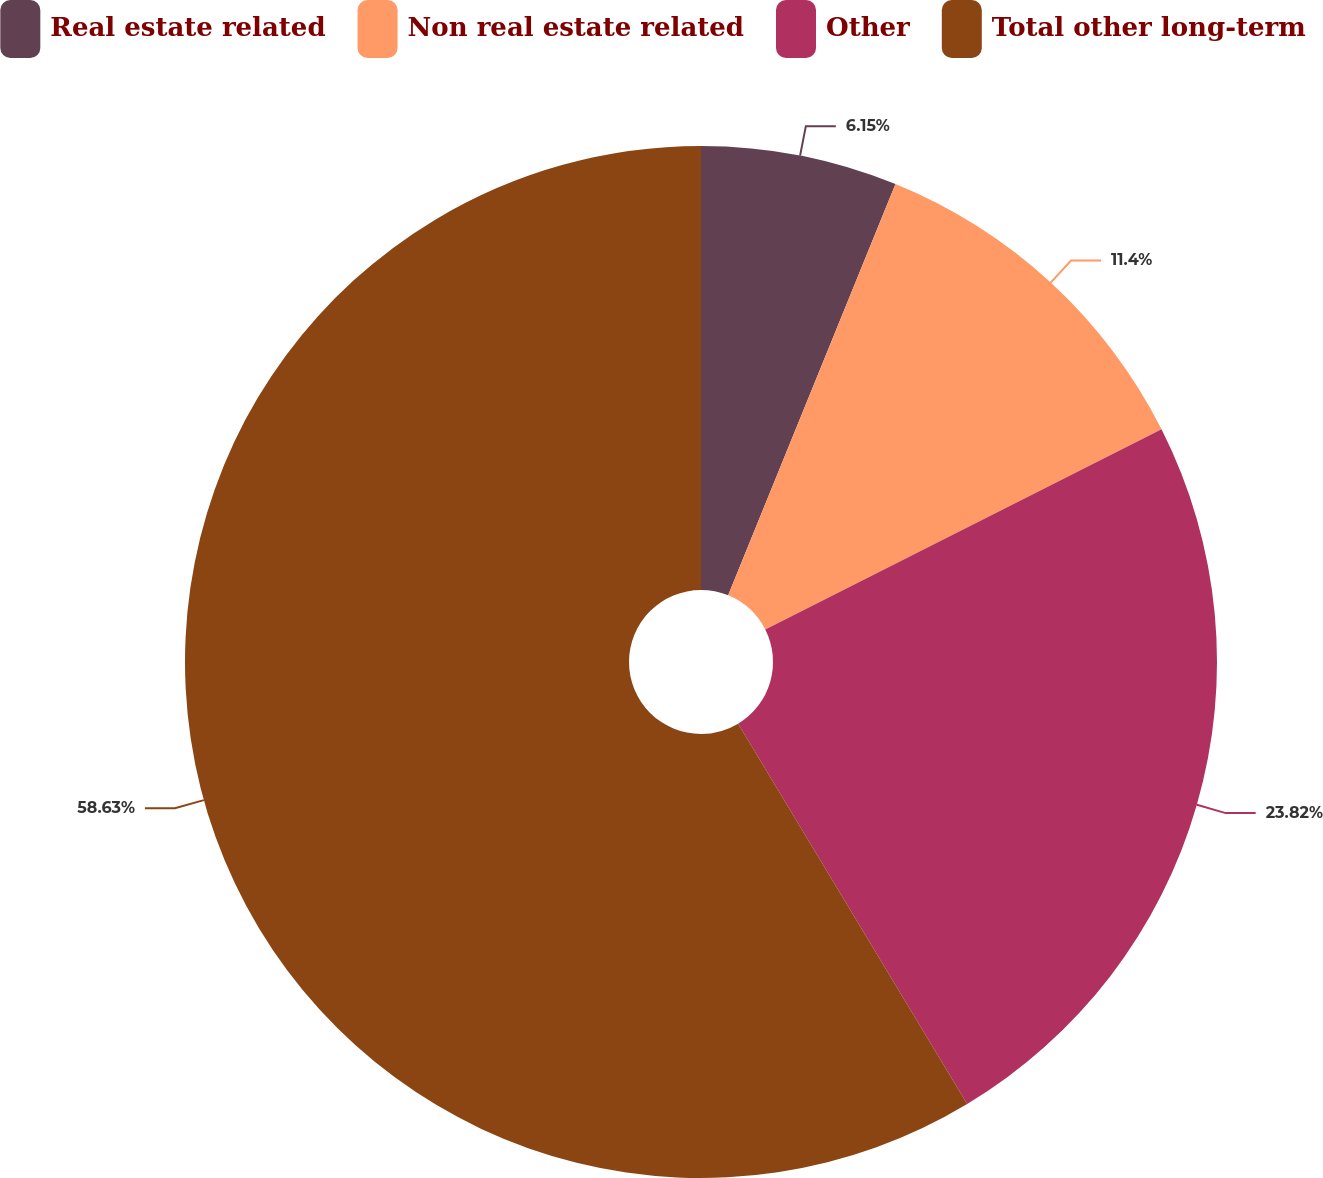Convert chart to OTSL. <chart><loc_0><loc_0><loc_500><loc_500><pie_chart><fcel>Real estate related<fcel>Non real estate related<fcel>Other<fcel>Total other long-term<nl><fcel>6.15%<fcel>11.4%<fcel>23.82%<fcel>58.62%<nl></chart> 